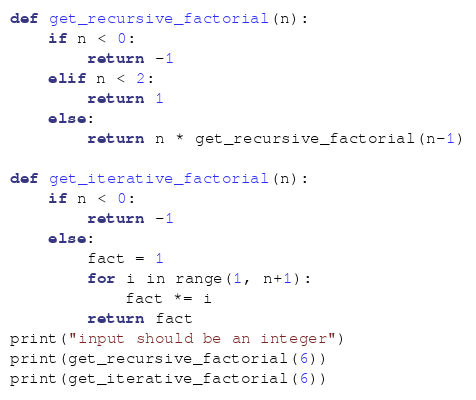Convert code to text. <code><loc_0><loc_0><loc_500><loc_500><_Python_>def get_recursive_factorial(n):
	if n < 0:
		return -1
	elif n < 2:
		return 1
	else:
		return n * get_recursive_factorial(n-1)
		
def get_iterative_factorial(n):
	if n < 0:
		return -1
	else:
		fact = 1
		for i in range(1, n+1):
			fact *= i
		return fact
print("input should be an integer")		
print(get_recursive_factorial(6))
print(get_iterative_factorial(6))
</code> 